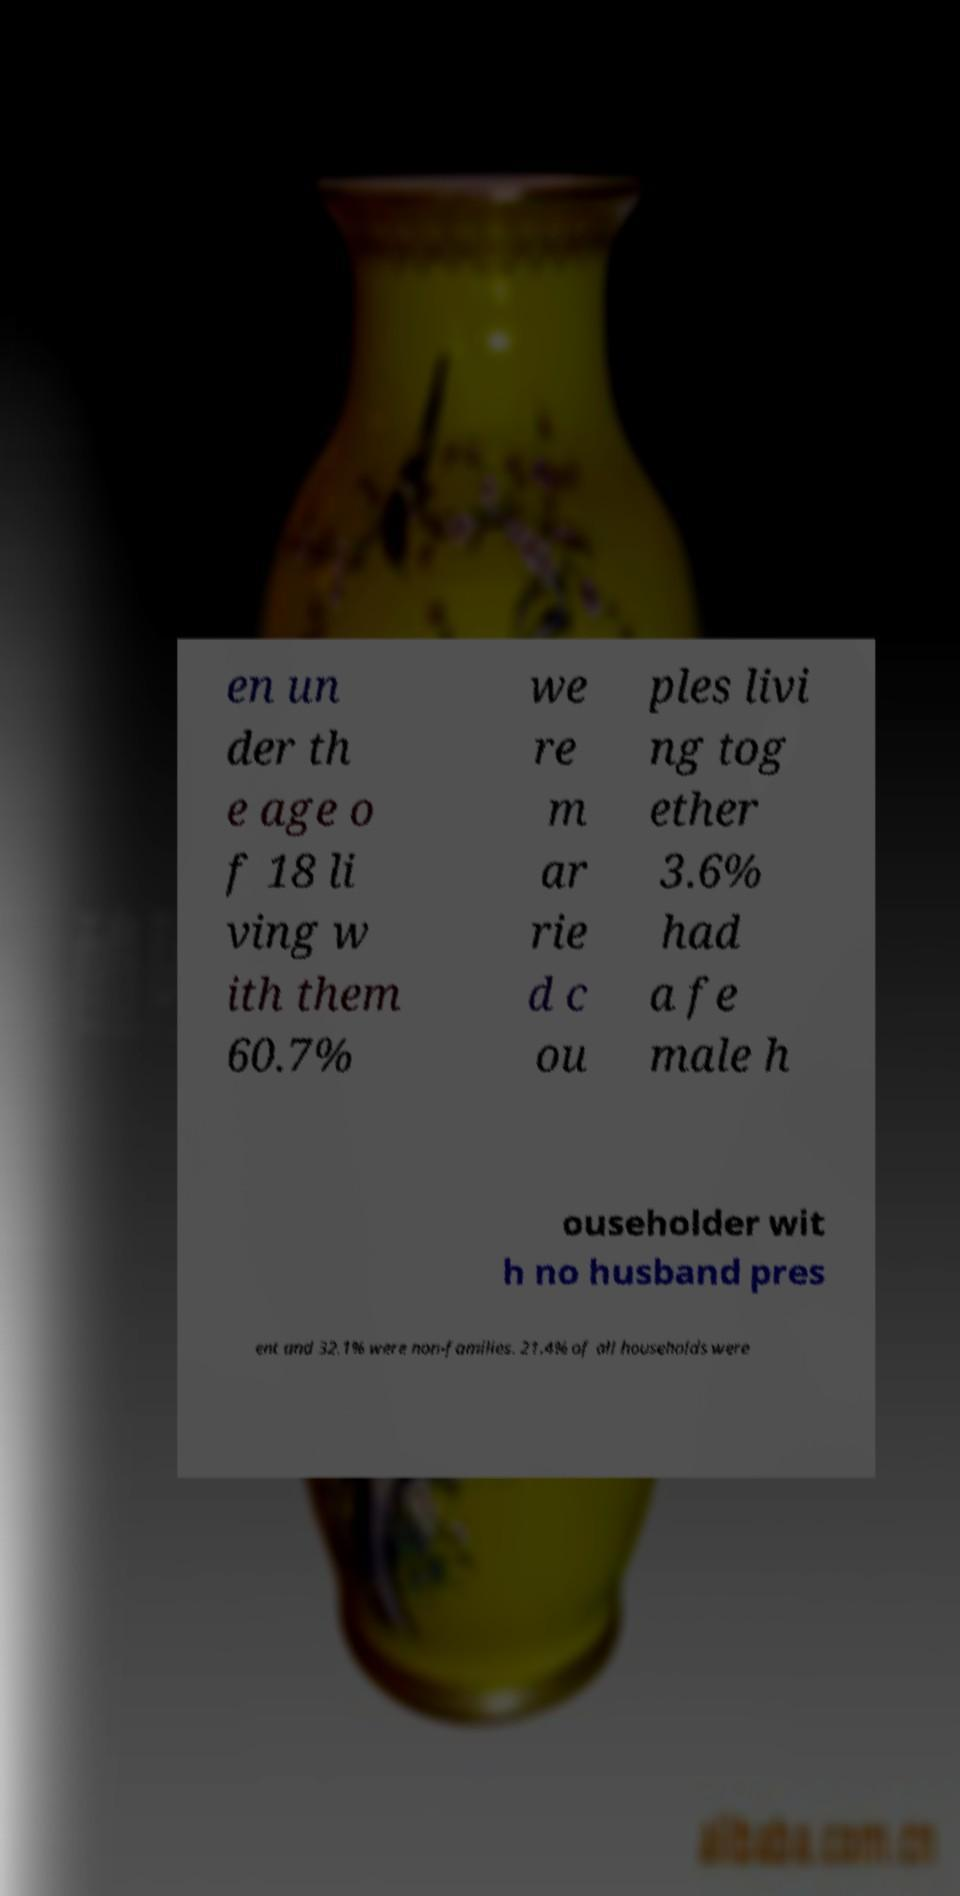What messages or text are displayed in this image? I need them in a readable, typed format. en un der th e age o f 18 li ving w ith them 60.7% we re m ar rie d c ou ples livi ng tog ether 3.6% had a fe male h ouseholder wit h no husband pres ent and 32.1% were non-families. 21.4% of all households were 